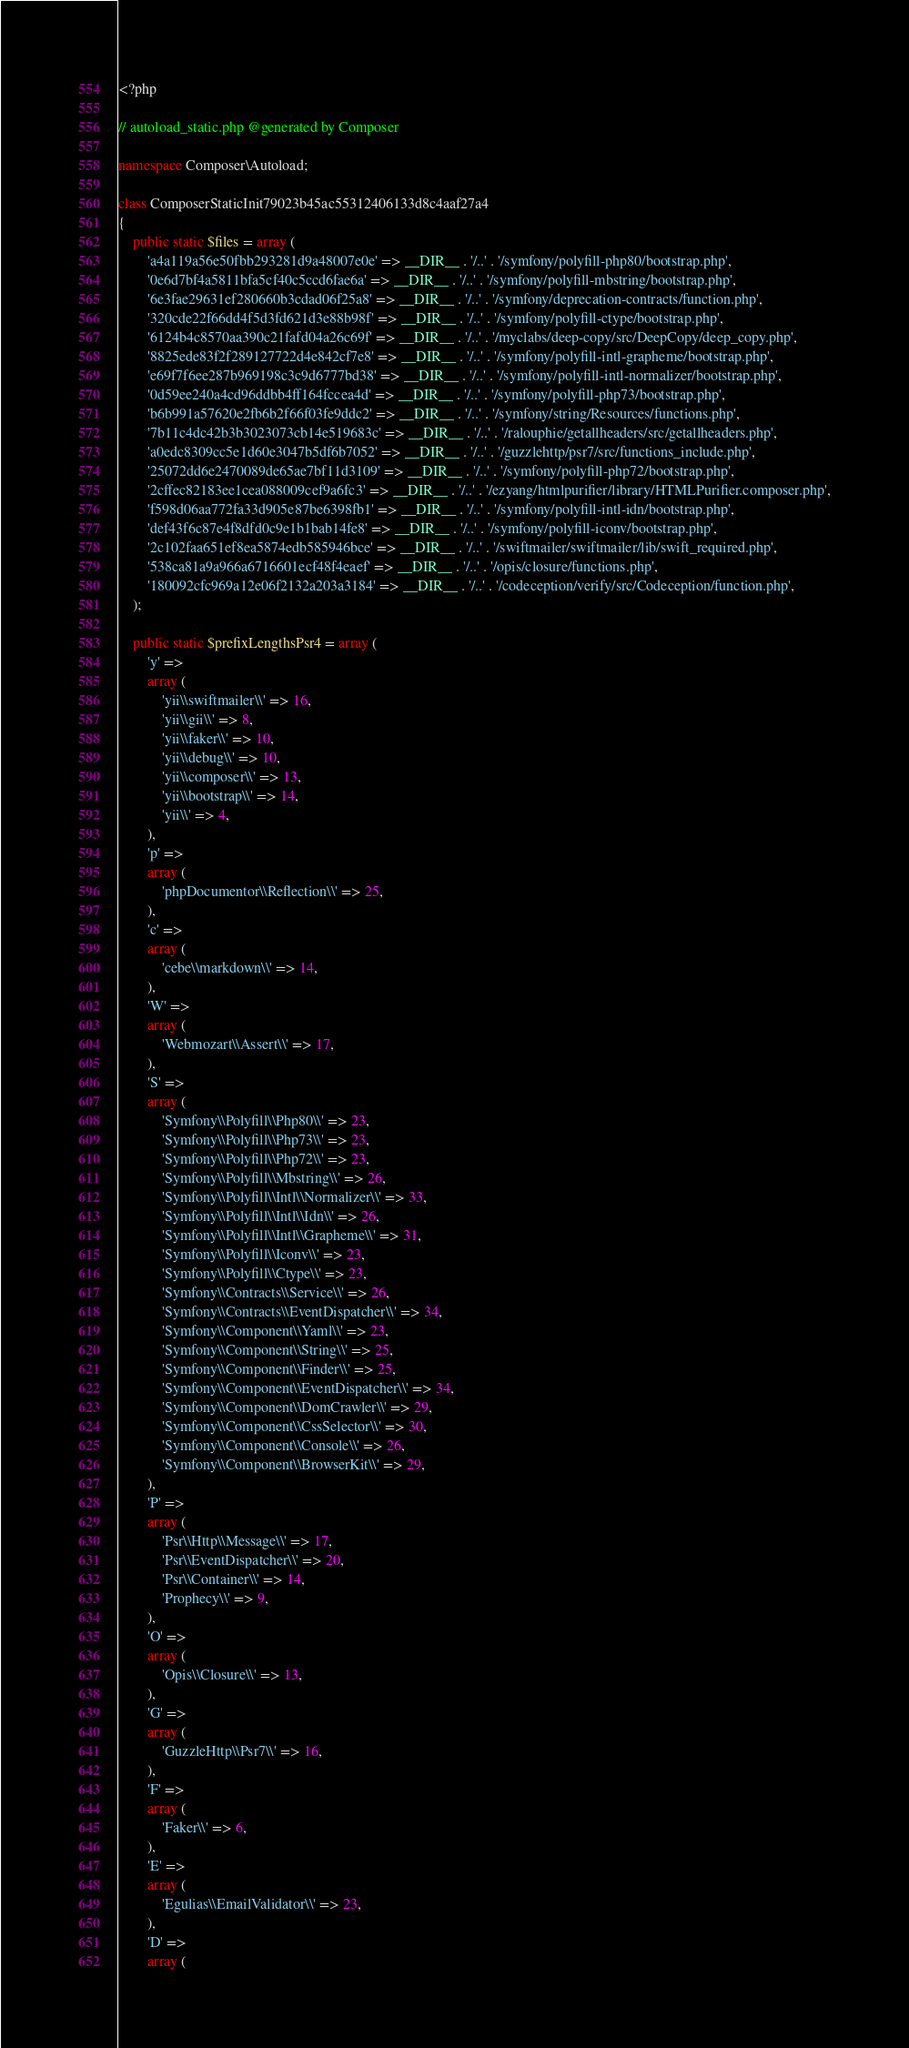<code> <loc_0><loc_0><loc_500><loc_500><_PHP_><?php

// autoload_static.php @generated by Composer

namespace Composer\Autoload;

class ComposerStaticInit79023b45ac55312406133d8c4aaf27a4
{
    public static $files = array (
        'a4a119a56e50fbb293281d9a48007e0e' => __DIR__ . '/..' . '/symfony/polyfill-php80/bootstrap.php',
        '0e6d7bf4a5811bfa5cf40c5ccd6fae6a' => __DIR__ . '/..' . '/symfony/polyfill-mbstring/bootstrap.php',
        '6e3fae29631ef280660b3cdad06f25a8' => __DIR__ . '/..' . '/symfony/deprecation-contracts/function.php',
        '320cde22f66dd4f5d3fd621d3e88b98f' => __DIR__ . '/..' . '/symfony/polyfill-ctype/bootstrap.php',
        '6124b4c8570aa390c21fafd04a26c69f' => __DIR__ . '/..' . '/myclabs/deep-copy/src/DeepCopy/deep_copy.php',
        '8825ede83f2f289127722d4e842cf7e8' => __DIR__ . '/..' . '/symfony/polyfill-intl-grapheme/bootstrap.php',
        'e69f7f6ee287b969198c3c9d6777bd38' => __DIR__ . '/..' . '/symfony/polyfill-intl-normalizer/bootstrap.php',
        '0d59ee240a4cd96ddbb4ff164fccea4d' => __DIR__ . '/..' . '/symfony/polyfill-php73/bootstrap.php',
        'b6b991a57620e2fb6b2f66f03fe9ddc2' => __DIR__ . '/..' . '/symfony/string/Resources/functions.php',
        '7b11c4dc42b3b3023073cb14e519683c' => __DIR__ . '/..' . '/ralouphie/getallheaders/src/getallheaders.php',
        'a0edc8309cc5e1d60e3047b5df6b7052' => __DIR__ . '/..' . '/guzzlehttp/psr7/src/functions_include.php',
        '25072dd6e2470089de65ae7bf11d3109' => __DIR__ . '/..' . '/symfony/polyfill-php72/bootstrap.php',
        '2cffec82183ee1cea088009cef9a6fc3' => __DIR__ . '/..' . '/ezyang/htmlpurifier/library/HTMLPurifier.composer.php',
        'f598d06aa772fa33d905e87be6398fb1' => __DIR__ . '/..' . '/symfony/polyfill-intl-idn/bootstrap.php',
        'def43f6c87e4f8dfd0c9e1b1bab14fe8' => __DIR__ . '/..' . '/symfony/polyfill-iconv/bootstrap.php',
        '2c102faa651ef8ea5874edb585946bce' => __DIR__ . '/..' . '/swiftmailer/swiftmailer/lib/swift_required.php',
        '538ca81a9a966a6716601ecf48f4eaef' => __DIR__ . '/..' . '/opis/closure/functions.php',
        '180092cfc969a12e06f2132a203a3184' => __DIR__ . '/..' . '/codeception/verify/src/Codeception/function.php',
    );

    public static $prefixLengthsPsr4 = array (
        'y' => 
        array (
            'yii\\swiftmailer\\' => 16,
            'yii\\gii\\' => 8,
            'yii\\faker\\' => 10,
            'yii\\debug\\' => 10,
            'yii\\composer\\' => 13,
            'yii\\bootstrap\\' => 14,
            'yii\\' => 4,
        ),
        'p' => 
        array (
            'phpDocumentor\\Reflection\\' => 25,
        ),
        'c' => 
        array (
            'cebe\\markdown\\' => 14,
        ),
        'W' => 
        array (
            'Webmozart\\Assert\\' => 17,
        ),
        'S' => 
        array (
            'Symfony\\Polyfill\\Php80\\' => 23,
            'Symfony\\Polyfill\\Php73\\' => 23,
            'Symfony\\Polyfill\\Php72\\' => 23,
            'Symfony\\Polyfill\\Mbstring\\' => 26,
            'Symfony\\Polyfill\\Intl\\Normalizer\\' => 33,
            'Symfony\\Polyfill\\Intl\\Idn\\' => 26,
            'Symfony\\Polyfill\\Intl\\Grapheme\\' => 31,
            'Symfony\\Polyfill\\Iconv\\' => 23,
            'Symfony\\Polyfill\\Ctype\\' => 23,
            'Symfony\\Contracts\\Service\\' => 26,
            'Symfony\\Contracts\\EventDispatcher\\' => 34,
            'Symfony\\Component\\Yaml\\' => 23,
            'Symfony\\Component\\String\\' => 25,
            'Symfony\\Component\\Finder\\' => 25,
            'Symfony\\Component\\EventDispatcher\\' => 34,
            'Symfony\\Component\\DomCrawler\\' => 29,
            'Symfony\\Component\\CssSelector\\' => 30,
            'Symfony\\Component\\Console\\' => 26,
            'Symfony\\Component\\BrowserKit\\' => 29,
        ),
        'P' => 
        array (
            'Psr\\Http\\Message\\' => 17,
            'Psr\\EventDispatcher\\' => 20,
            'Psr\\Container\\' => 14,
            'Prophecy\\' => 9,
        ),
        'O' => 
        array (
            'Opis\\Closure\\' => 13,
        ),
        'G' => 
        array (
            'GuzzleHttp\\Psr7\\' => 16,
        ),
        'F' => 
        array (
            'Faker\\' => 6,
        ),
        'E' => 
        array (
            'Egulias\\EmailValidator\\' => 23,
        ),
        'D' => 
        array (</code> 